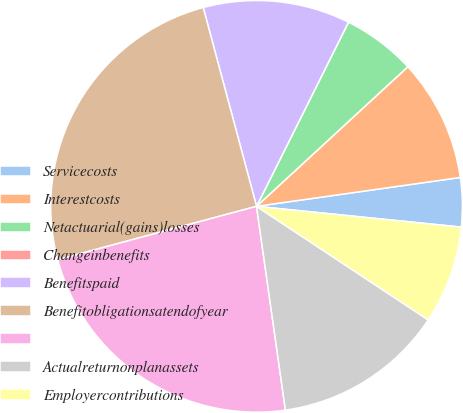<chart> <loc_0><loc_0><loc_500><loc_500><pie_chart><fcel>Servicecosts<fcel>Interestcosts<fcel>Netactuarial(gains)losses<fcel>Changeinbenefits<fcel>Benefitspaid<fcel>Benefitobligationsatendofyear<fcel>Unnamed: 6<fcel>Actualreturnonplanassets<fcel>Employercontributions<nl><fcel>3.85%<fcel>9.62%<fcel>5.77%<fcel>0.0%<fcel>11.54%<fcel>25.0%<fcel>23.07%<fcel>13.46%<fcel>7.69%<nl></chart> 